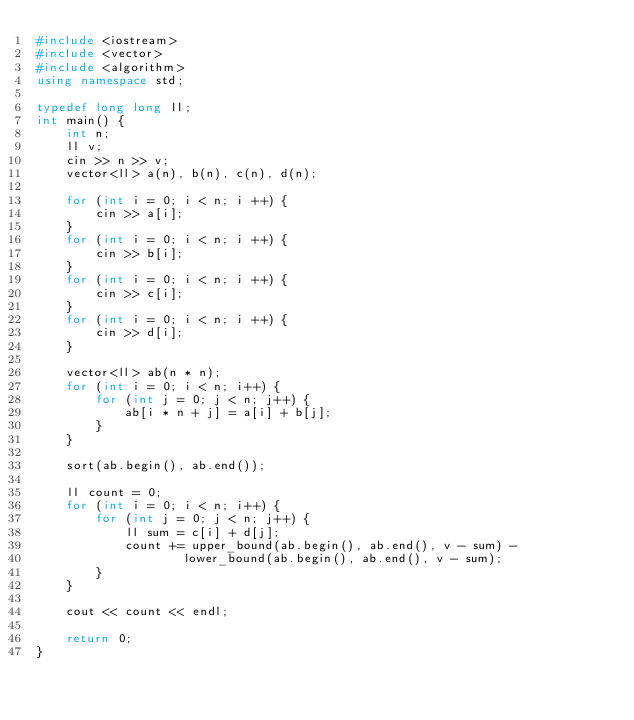Convert code to text. <code><loc_0><loc_0><loc_500><loc_500><_C++_>#include <iostream>
#include <vector>
#include <algorithm>
using namespace std;

typedef long long ll;
int main() {
    int n;
    ll v;
    cin >> n >> v;
    vector<ll> a(n), b(n), c(n), d(n);
    
    for (int i = 0; i < n; i ++) {
        cin >> a[i];
    }
    for (int i = 0; i < n; i ++) {
        cin >> b[i];
    }
    for (int i = 0; i < n; i ++) {
        cin >> c[i];
    }
    for (int i = 0; i < n; i ++) {
        cin >> d[i];
    }
    
    vector<ll> ab(n * n);
    for (int i = 0; i < n; i++) {
        for (int j = 0; j < n; j++) {
            ab[i * n + j] = a[i] + b[j];
        }
    }
    
    sort(ab.begin(), ab.end());
    
    ll count = 0;
    for (int i = 0; i < n; i++) {
        for (int j = 0; j < n; j++) {
            ll sum = c[i] + d[j];
            count += upper_bound(ab.begin(), ab.end(), v - sum) - 
                    lower_bound(ab.begin(), ab.end(), v - sum);
        }
    }
    
    cout << count << endl;
    
    return 0;
}</code> 